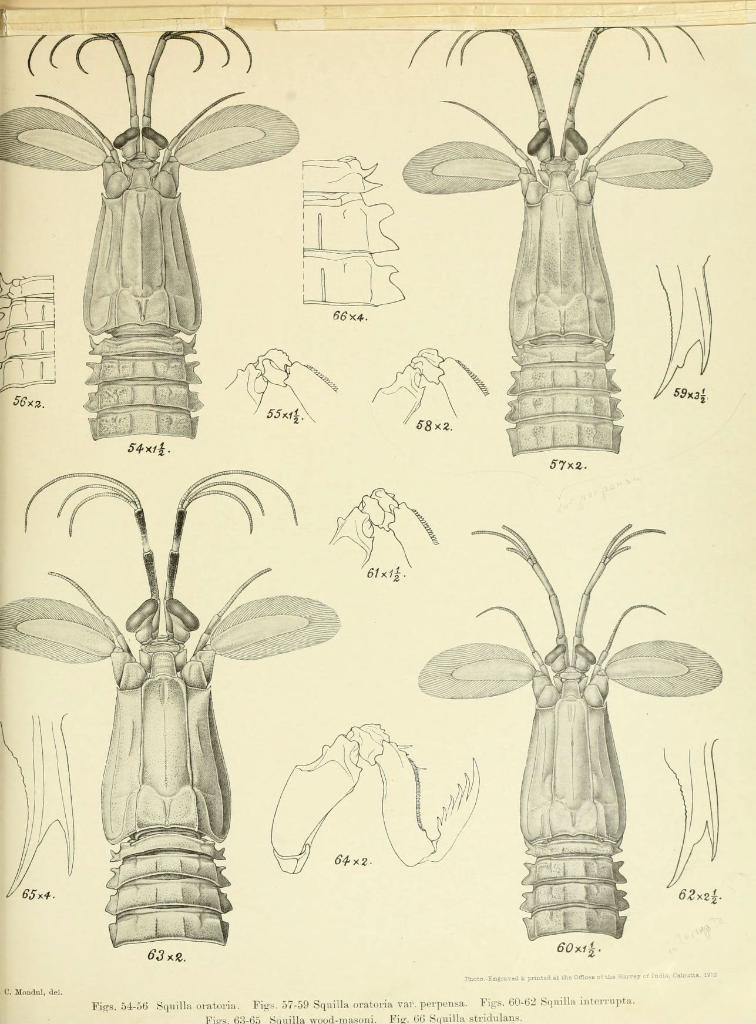What is depicted in the image? There is a sketch of insects in the image. What specific elements of insects are included in the sketch? The sketch includes parts of insects. What type of coal is visible in the image? There is no coal present in the image; it features a sketch of insects. What kind of beast can be seen interacting with the insects in the image? There is no beast present in the image; it only features a sketch of insects and their parts. 